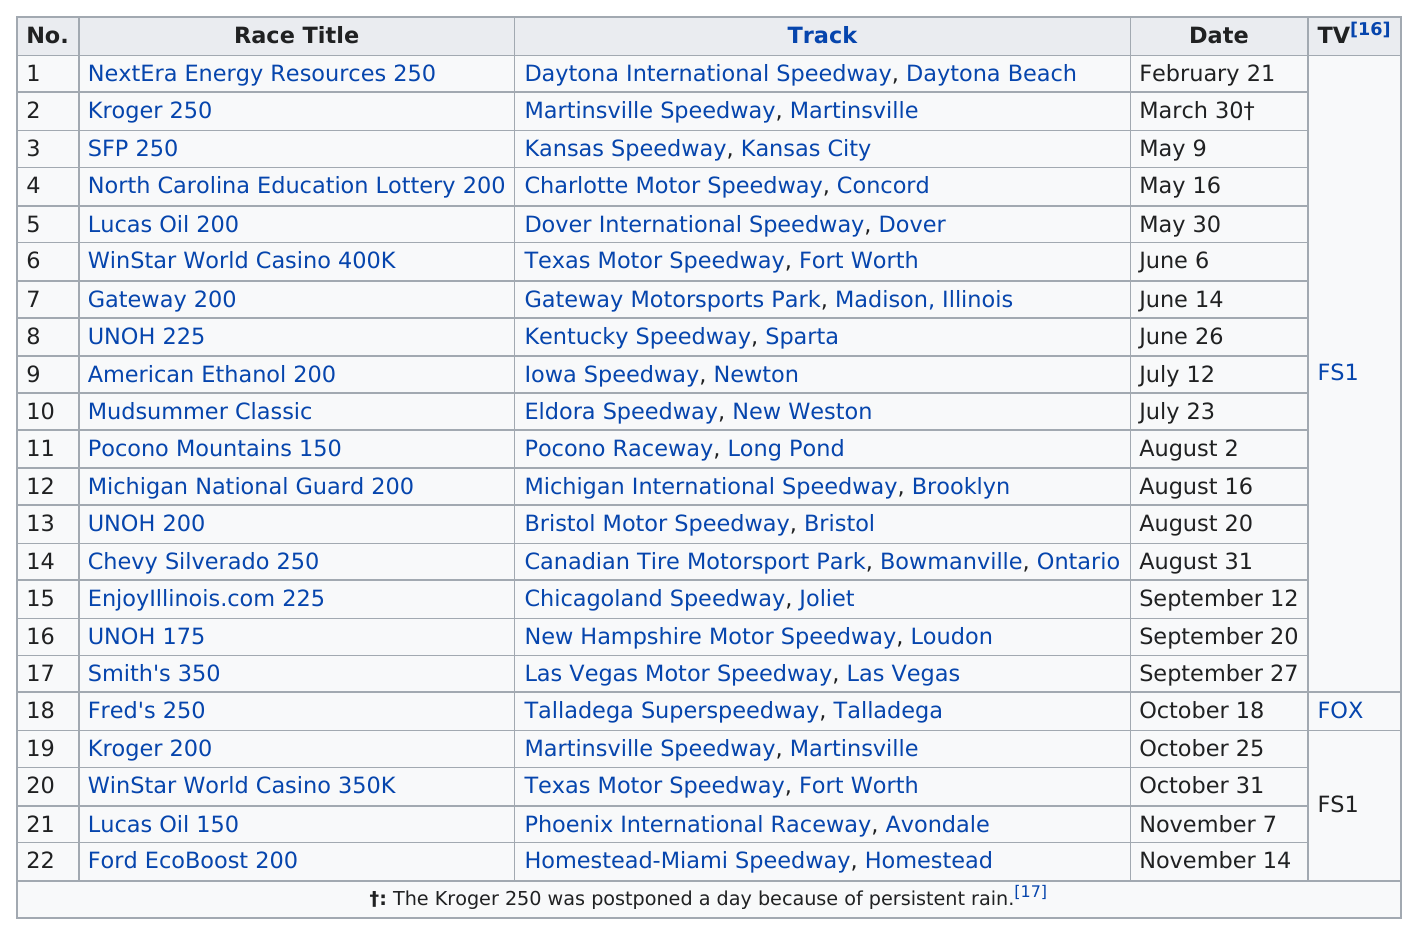List a handful of essential elements in this visual. The total number of races that took place in Fort Worth is 1. The first race was named NextEra Energy Resources 250. The Kroger 250 race was not held on its scheduled day. Fred's 250, a race from the top-rated television network, was showcased. The race that occurred before the SFP 250 was the Kroger 250. 